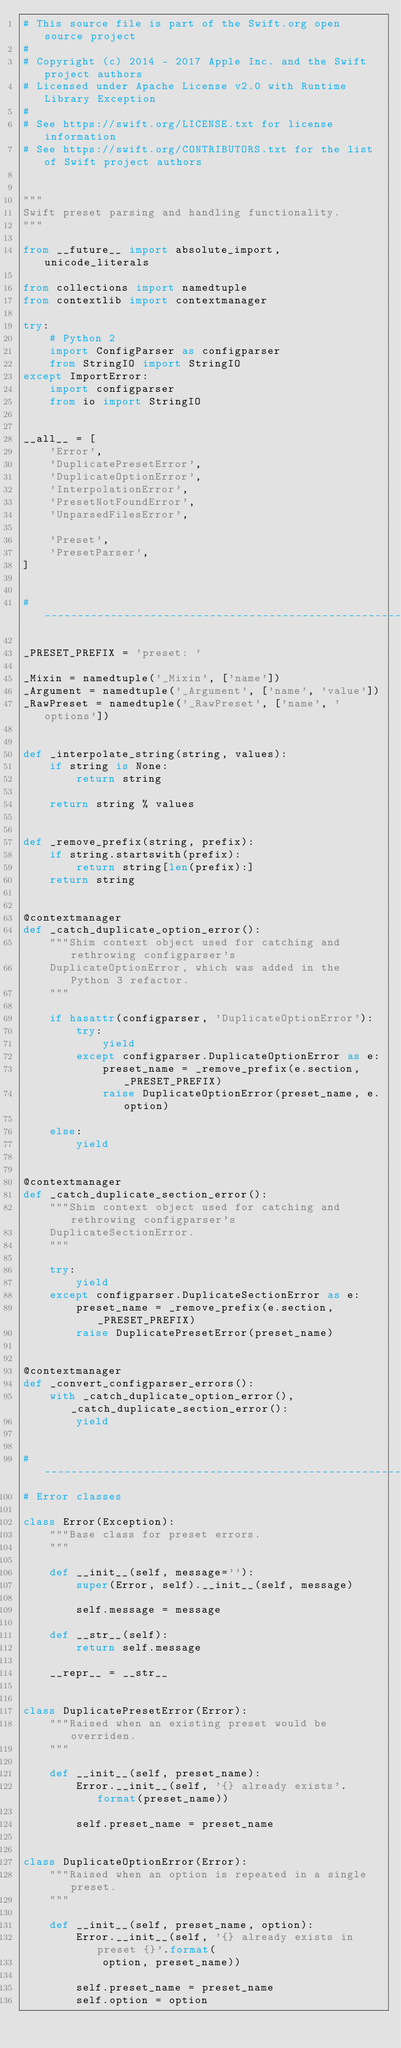<code> <loc_0><loc_0><loc_500><loc_500><_Python_># This source file is part of the Swift.org open source project
#
# Copyright (c) 2014 - 2017 Apple Inc. and the Swift project authors
# Licensed under Apache License v2.0 with Runtime Library Exception
#
# See https://swift.org/LICENSE.txt for license information
# See https://swift.org/CONTRIBUTORS.txt for the list of Swift project authors


"""
Swift preset parsing and handling functionality.
"""

from __future__ import absolute_import, unicode_literals

from collections import namedtuple
from contextlib import contextmanager

try:
    # Python 2
    import ConfigParser as configparser
    from StringIO import StringIO
except ImportError:
    import configparser
    from io import StringIO


__all__ = [
    'Error',
    'DuplicatePresetError',
    'DuplicateOptionError',
    'InterpolationError',
    'PresetNotFoundError',
    'UnparsedFilesError',

    'Preset',
    'PresetParser',
]


# -----------------------------------------------------------------------------

_PRESET_PREFIX = 'preset: '

_Mixin = namedtuple('_Mixin', ['name'])
_Argument = namedtuple('_Argument', ['name', 'value'])
_RawPreset = namedtuple('_RawPreset', ['name', 'options'])


def _interpolate_string(string, values):
    if string is None:
        return string

    return string % values


def _remove_prefix(string, prefix):
    if string.startswith(prefix):
        return string[len(prefix):]
    return string


@contextmanager
def _catch_duplicate_option_error():
    """Shim context object used for catching and rethrowing configparser's
    DuplicateOptionError, which was added in the Python 3 refactor.
    """

    if hasattr(configparser, 'DuplicateOptionError'):
        try:
            yield
        except configparser.DuplicateOptionError as e:
            preset_name = _remove_prefix(e.section, _PRESET_PREFIX)
            raise DuplicateOptionError(preset_name, e.option)

    else:
        yield


@contextmanager
def _catch_duplicate_section_error():
    """Shim context object used for catching and rethrowing configparser's
    DuplicateSectionError.
    """

    try:
        yield
    except configparser.DuplicateSectionError as e:
        preset_name = _remove_prefix(e.section, _PRESET_PREFIX)
        raise DuplicatePresetError(preset_name)


@contextmanager
def _convert_configparser_errors():
    with _catch_duplicate_option_error(), _catch_duplicate_section_error():
        yield


# -----------------------------------------------------------------------------
# Error classes

class Error(Exception):
    """Base class for preset errors.
    """

    def __init__(self, message=''):
        super(Error, self).__init__(self, message)

        self.message = message

    def __str__(self):
        return self.message

    __repr__ = __str__


class DuplicatePresetError(Error):
    """Raised when an existing preset would be overriden.
    """

    def __init__(self, preset_name):
        Error.__init__(self, '{} already exists'.format(preset_name))

        self.preset_name = preset_name


class DuplicateOptionError(Error):
    """Raised when an option is repeated in a single preset.
    """

    def __init__(self, preset_name, option):
        Error.__init__(self, '{} already exists in preset {}'.format(
            option, preset_name))

        self.preset_name = preset_name
        self.option = option

</code> 